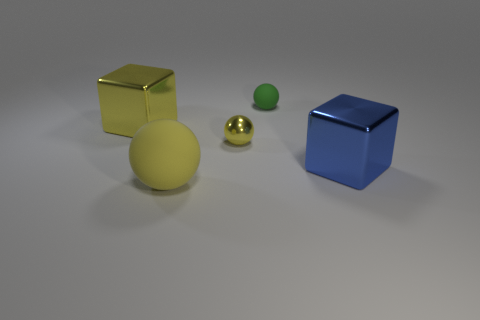Add 3 yellow shiny spheres. How many objects exist? 8 Subtract all blocks. How many objects are left? 3 Subtract 0 green blocks. How many objects are left? 5 Subtract all yellow shiny blocks. Subtract all big yellow blocks. How many objects are left? 3 Add 1 tiny yellow metal balls. How many tiny yellow metal balls are left? 2 Add 3 big red rubber cylinders. How many big red rubber cylinders exist? 3 